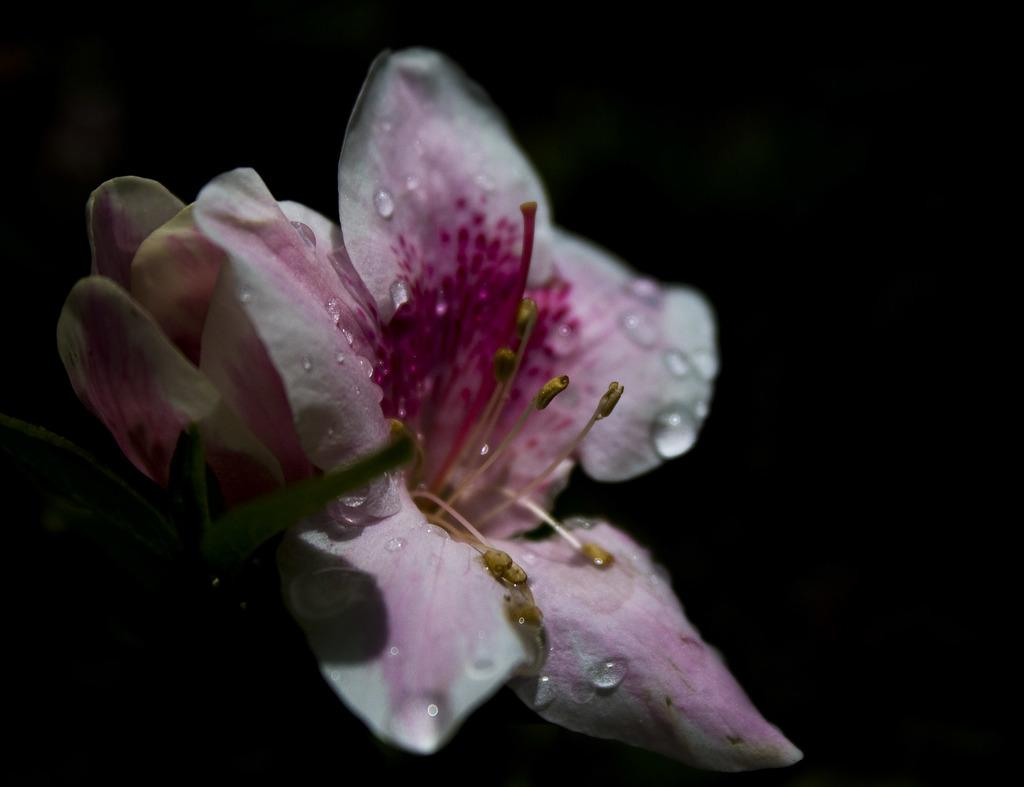What is the main subject of the image? There is a flower in the center of the image. Can you describe the flower in more detail? Yes, there are water drops on the flower. What can be observed about the overall appearance of the image? The background of the image is dark. What type of religious ceremony is taking place in the image? There is no indication of a religious ceremony in the image; it features a flower with water drops and a dark background. What flavor of cake is shown in the image? There is no cake present in the image; it features a flower with water drops and a dark background. 